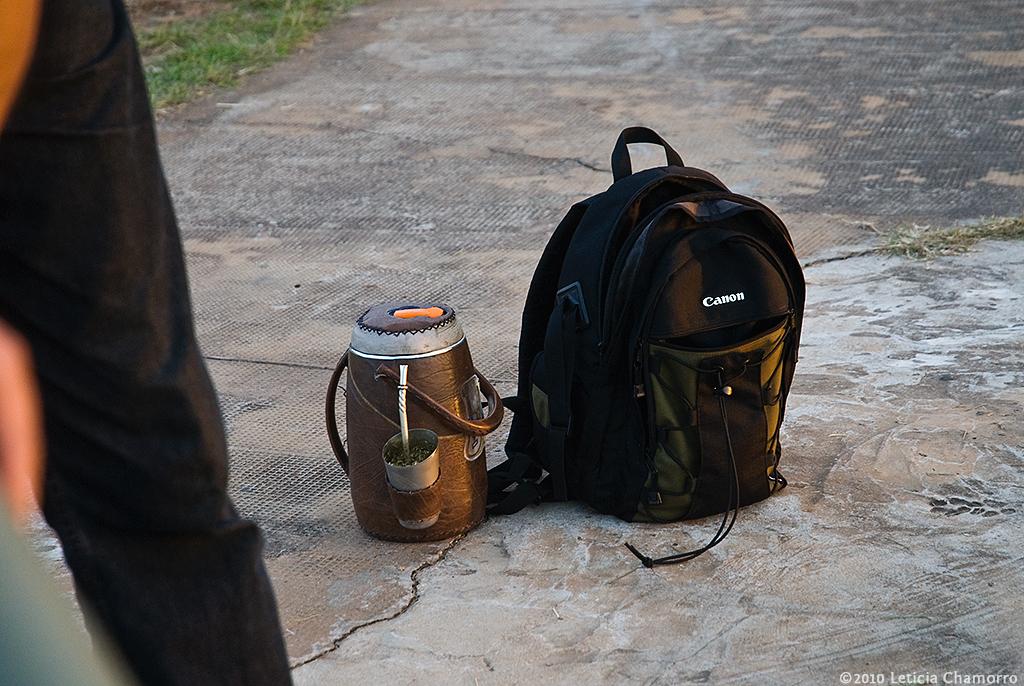What brand is the backpack from?
Offer a very short reply. Canon. Who is the copywrite on the photo?
Your answer should be compact. Leticia chamorro. 